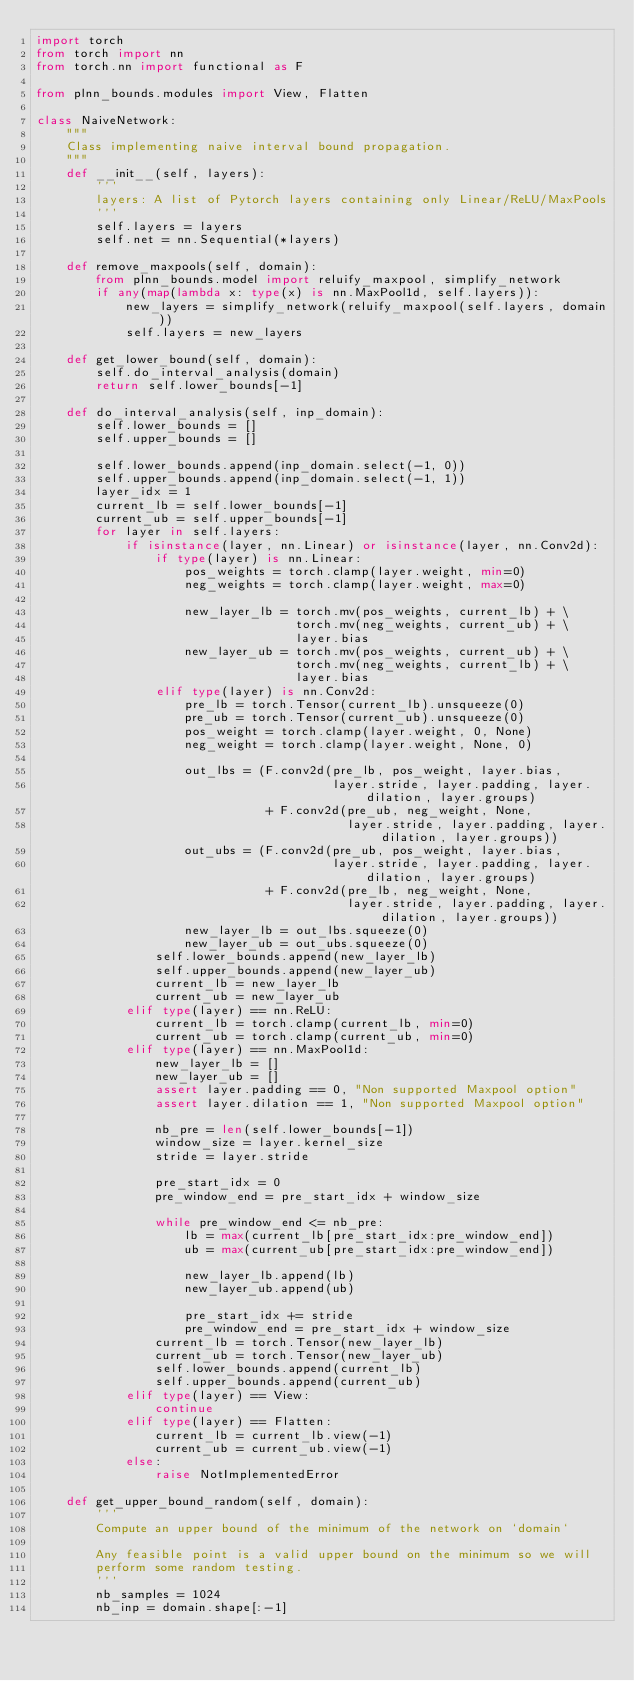<code> <loc_0><loc_0><loc_500><loc_500><_Python_>import torch
from torch import nn
from torch.nn import functional as F

from plnn_bounds.modules import View, Flatten

class NaiveNetwork:
    """
    Class implementing naive interval bound propagation.
    """
    def __init__(self, layers):
        '''
        layers: A list of Pytorch layers containing only Linear/ReLU/MaxPools
        '''
        self.layers = layers
        self.net = nn.Sequential(*layers)

    def remove_maxpools(self, domain):
        from plnn_bounds.model import reluify_maxpool, simplify_network
        if any(map(lambda x: type(x) is nn.MaxPool1d, self.layers)):
            new_layers = simplify_network(reluify_maxpool(self.layers, domain))
            self.layers = new_layers

    def get_lower_bound(self, domain):
        self.do_interval_analysis(domain)
        return self.lower_bounds[-1]

    def do_interval_analysis(self, inp_domain):
        self.lower_bounds = []
        self.upper_bounds = []

        self.lower_bounds.append(inp_domain.select(-1, 0))
        self.upper_bounds.append(inp_domain.select(-1, 1))
        layer_idx = 1
        current_lb = self.lower_bounds[-1]
        current_ub = self.upper_bounds[-1]
        for layer in self.layers:
            if isinstance(layer, nn.Linear) or isinstance(layer, nn.Conv2d):
                if type(layer) is nn.Linear:
                    pos_weights = torch.clamp(layer.weight, min=0)
                    neg_weights = torch.clamp(layer.weight, max=0)

                    new_layer_lb = torch.mv(pos_weights, current_lb) + \
                                   torch.mv(neg_weights, current_ub) + \
                                   layer.bias
                    new_layer_ub = torch.mv(pos_weights, current_ub) + \
                                   torch.mv(neg_weights, current_lb) + \
                                   layer.bias
                elif type(layer) is nn.Conv2d:
                    pre_lb = torch.Tensor(current_lb).unsqueeze(0)
                    pre_ub = torch.Tensor(current_ub).unsqueeze(0)
                    pos_weight = torch.clamp(layer.weight, 0, None)
                    neg_weight = torch.clamp(layer.weight, None, 0)

                    out_lbs = (F.conv2d(pre_lb, pos_weight, layer.bias,
                                        layer.stride, layer.padding, layer.dilation, layer.groups)
                               + F.conv2d(pre_ub, neg_weight, None,
                                          layer.stride, layer.padding, layer.dilation, layer.groups))
                    out_ubs = (F.conv2d(pre_ub, pos_weight, layer.bias,
                                        layer.stride, layer.padding, layer.dilation, layer.groups)
                               + F.conv2d(pre_lb, neg_weight, None,
                                          layer.stride, layer.padding, layer.dilation, layer.groups))
                    new_layer_lb = out_lbs.squeeze(0)
                    new_layer_ub = out_ubs.squeeze(0)
                self.lower_bounds.append(new_layer_lb)
                self.upper_bounds.append(new_layer_ub)
                current_lb = new_layer_lb
                current_ub = new_layer_ub
            elif type(layer) == nn.ReLU:
                current_lb = torch.clamp(current_lb, min=0)
                current_ub = torch.clamp(current_ub, min=0)
            elif type(layer) == nn.MaxPool1d:
                new_layer_lb = []
                new_layer_ub = []
                assert layer.padding == 0, "Non supported Maxpool option"
                assert layer.dilation == 1, "Non supported Maxpool option"

                nb_pre = len(self.lower_bounds[-1])
                window_size = layer.kernel_size
                stride = layer.stride

                pre_start_idx = 0
                pre_window_end = pre_start_idx + window_size

                while pre_window_end <= nb_pre:
                    lb = max(current_lb[pre_start_idx:pre_window_end])
                    ub = max(current_ub[pre_start_idx:pre_window_end])

                    new_layer_lb.append(lb)
                    new_layer_ub.append(ub)

                    pre_start_idx += stride
                    pre_window_end = pre_start_idx + window_size
                current_lb = torch.Tensor(new_layer_lb)
                current_ub = torch.Tensor(new_layer_ub)
                self.lower_bounds.append(current_lb)
                self.upper_bounds.append(current_ub)
            elif type(layer) == View:
                continue
            elif type(layer) == Flatten:
                current_lb = current_lb.view(-1)
                current_ub = current_ub.view(-1)
            else:
                raise NotImplementedError

    def get_upper_bound_random(self, domain):
        '''
        Compute an upper bound of the minimum of the network on `domain`

        Any feasible point is a valid upper bound on the minimum so we will
        perform some random testing.
        '''
        nb_samples = 1024
        nb_inp = domain.shape[:-1]</code> 